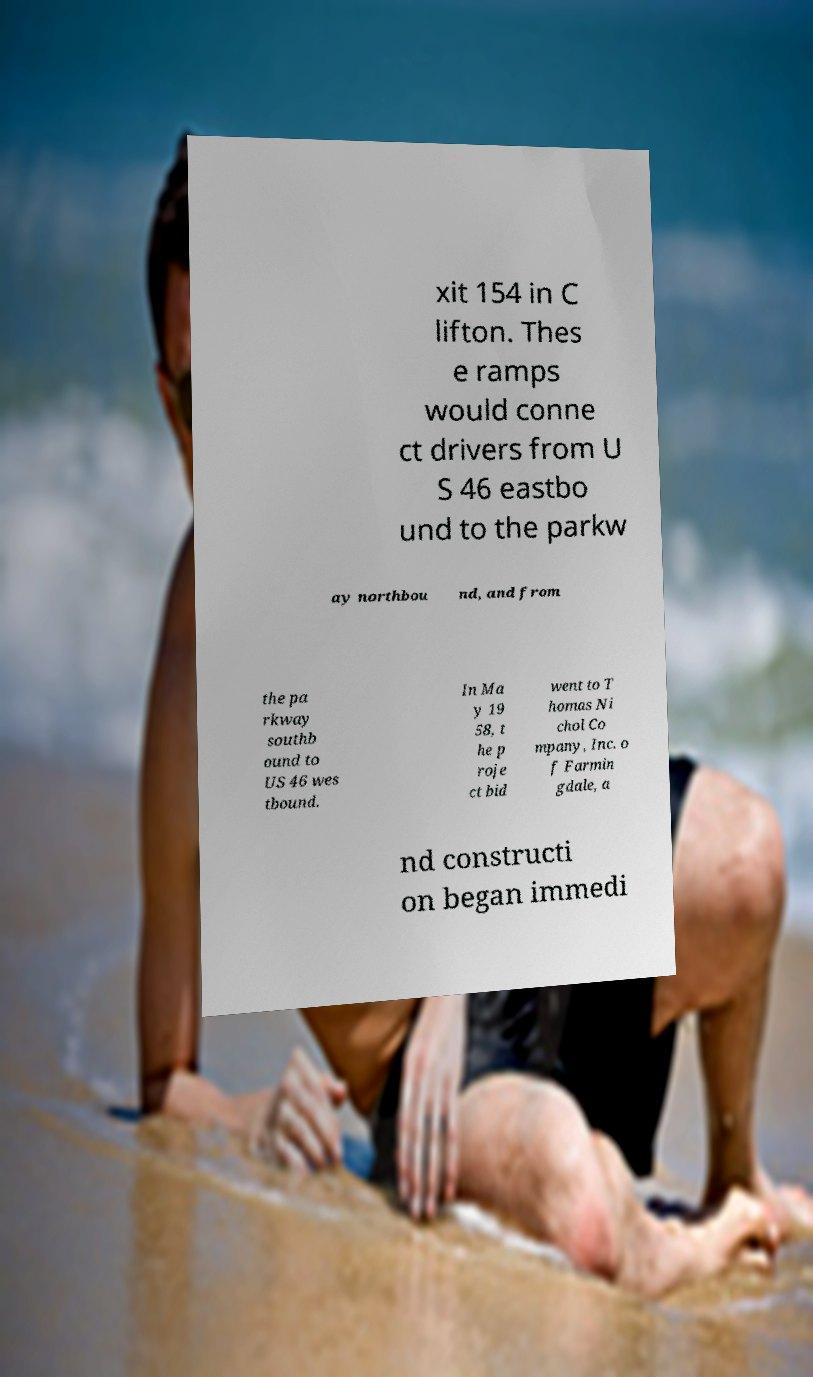Could you extract and type out the text from this image? xit 154 in C lifton. Thes e ramps would conne ct drivers from U S 46 eastbo und to the parkw ay northbou nd, and from the pa rkway southb ound to US 46 wes tbound. In Ma y 19 58, t he p roje ct bid went to T homas Ni chol Co mpany, Inc. o f Farmin gdale, a nd constructi on began immedi 